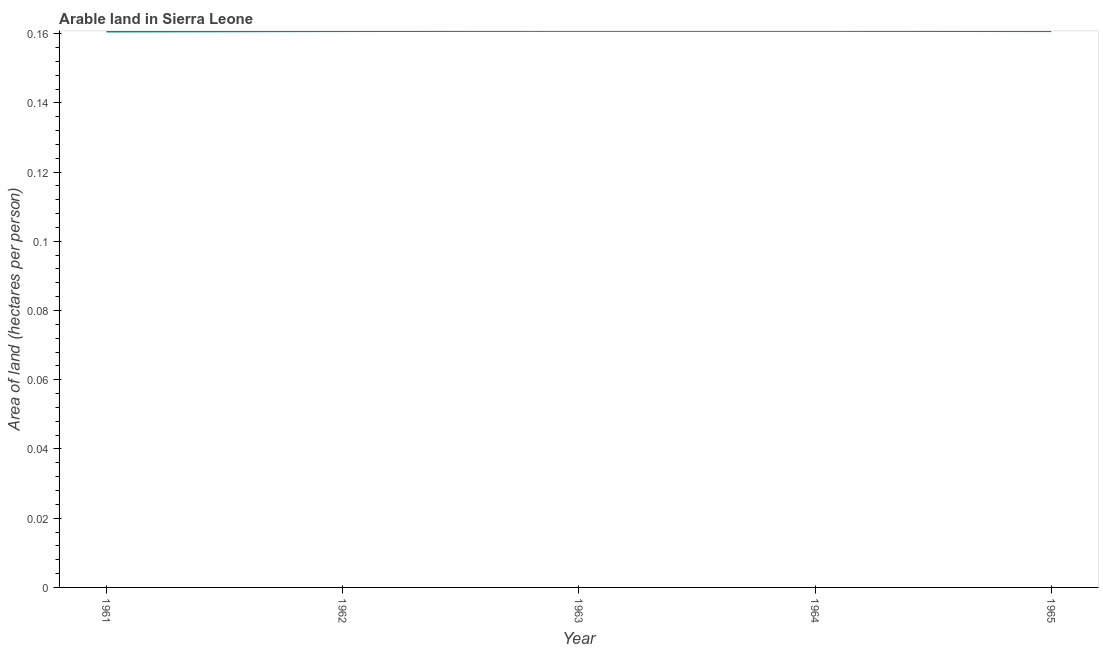What is the area of arable land in 1965?
Provide a short and direct response. 0.16. Across all years, what is the maximum area of arable land?
Offer a very short reply. 0.16. Across all years, what is the minimum area of arable land?
Offer a terse response. 0.16. What is the sum of the area of arable land?
Provide a short and direct response. 0.8. What is the difference between the area of arable land in 1961 and 1963?
Give a very brief answer. -0. What is the average area of arable land per year?
Provide a succinct answer. 0.16. What is the median area of arable land?
Offer a terse response. 0.16. Do a majority of the years between 1964 and 1965 (inclusive) have area of arable land greater than 0.064 hectares per person?
Provide a short and direct response. Yes. What is the ratio of the area of arable land in 1963 to that in 1965?
Ensure brevity in your answer.  1. Is the area of arable land in 1963 less than that in 1964?
Your answer should be very brief. No. What is the difference between the highest and the second highest area of arable land?
Your answer should be compact. 2.698604926992809e-6. Is the sum of the area of arable land in 1962 and 1965 greater than the maximum area of arable land across all years?
Your answer should be very brief. Yes. What is the difference between the highest and the lowest area of arable land?
Your answer should be compact. 0. In how many years, is the area of arable land greater than the average area of arable land taken over all years?
Your answer should be compact. 3. Does the area of arable land monotonically increase over the years?
Provide a succinct answer. No. What is the difference between two consecutive major ticks on the Y-axis?
Offer a terse response. 0.02. Are the values on the major ticks of Y-axis written in scientific E-notation?
Offer a terse response. No. Does the graph contain any zero values?
Your answer should be very brief. No. What is the title of the graph?
Ensure brevity in your answer.  Arable land in Sierra Leone. What is the label or title of the X-axis?
Your answer should be compact. Year. What is the label or title of the Y-axis?
Make the answer very short. Area of land (hectares per person). What is the Area of land (hectares per person) in 1961?
Ensure brevity in your answer.  0.16. What is the Area of land (hectares per person) of 1962?
Your answer should be compact. 0.16. What is the Area of land (hectares per person) of 1963?
Give a very brief answer. 0.16. What is the Area of land (hectares per person) of 1964?
Make the answer very short. 0.16. What is the Area of land (hectares per person) of 1965?
Make the answer very short. 0.16. What is the difference between the Area of land (hectares per person) in 1961 and 1962?
Offer a very short reply. -0. What is the difference between the Area of land (hectares per person) in 1961 and 1963?
Your answer should be very brief. -0. What is the difference between the Area of land (hectares per person) in 1961 and 1964?
Your answer should be compact. -0. What is the difference between the Area of land (hectares per person) in 1961 and 1965?
Your answer should be very brief. -0. What is the difference between the Area of land (hectares per person) in 1962 and 1963?
Provide a short and direct response. -6e-5. What is the difference between the Area of land (hectares per person) in 1962 and 1964?
Make the answer very short. -5e-5. What is the difference between the Area of land (hectares per person) in 1962 and 1965?
Keep it short and to the point. 1e-5. What is the difference between the Area of land (hectares per person) in 1963 and 1965?
Offer a very short reply. 6e-5. What is the difference between the Area of land (hectares per person) in 1964 and 1965?
Make the answer very short. 6e-5. What is the ratio of the Area of land (hectares per person) in 1961 to that in 1965?
Offer a very short reply. 1. What is the ratio of the Area of land (hectares per person) in 1962 to that in 1963?
Give a very brief answer. 1. What is the ratio of the Area of land (hectares per person) in 1963 to that in 1964?
Give a very brief answer. 1. What is the ratio of the Area of land (hectares per person) in 1963 to that in 1965?
Your response must be concise. 1. 